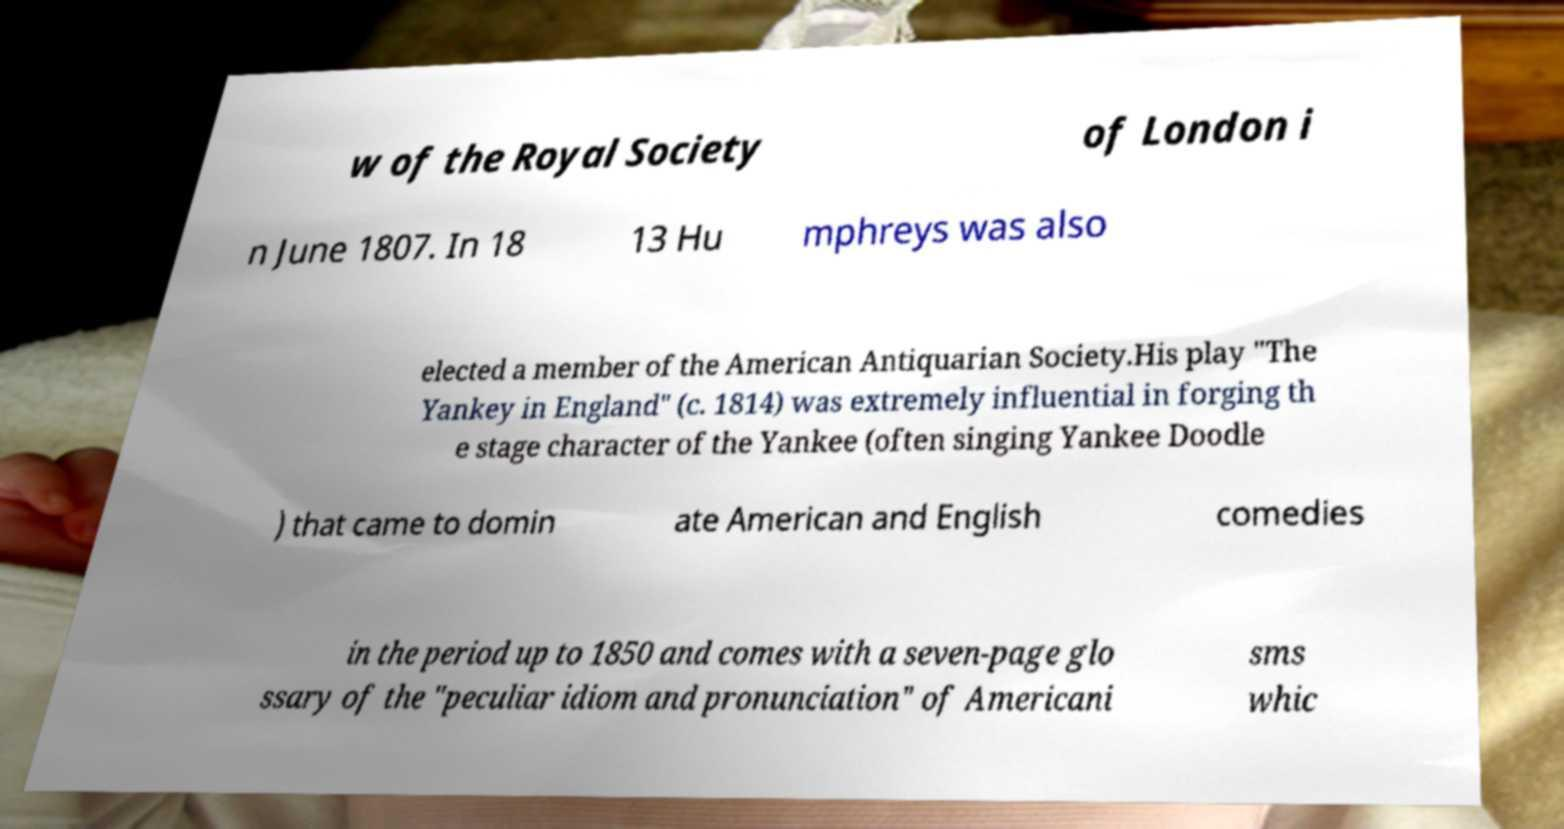Can you accurately transcribe the text from the provided image for me? w of the Royal Society of London i n June 1807. In 18 13 Hu mphreys was also elected a member of the American Antiquarian Society.His play "The Yankey in England" (c. 1814) was extremely influential in forging th e stage character of the Yankee (often singing Yankee Doodle ) that came to domin ate American and English comedies in the period up to 1850 and comes with a seven-page glo ssary of the "peculiar idiom and pronunciation" of Americani sms whic 